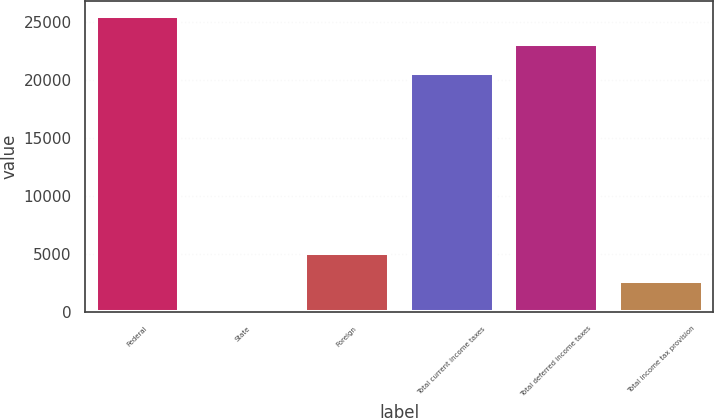<chart> <loc_0><loc_0><loc_500><loc_500><bar_chart><fcel>Federal<fcel>State<fcel>Foreign<fcel>Total current income taxes<fcel>Total deferred income taxes<fcel>Total income tax provision<nl><fcel>25531.6<fcel>208<fcel>5114.6<fcel>20625<fcel>23078.3<fcel>2661.3<nl></chart> 